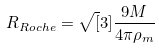Convert formula to latex. <formula><loc_0><loc_0><loc_500><loc_500>R _ { R o c h e } = \sqrt { [ } 3 ] { \frac { 9 M } { 4 \pi \rho _ { m } } }</formula> 